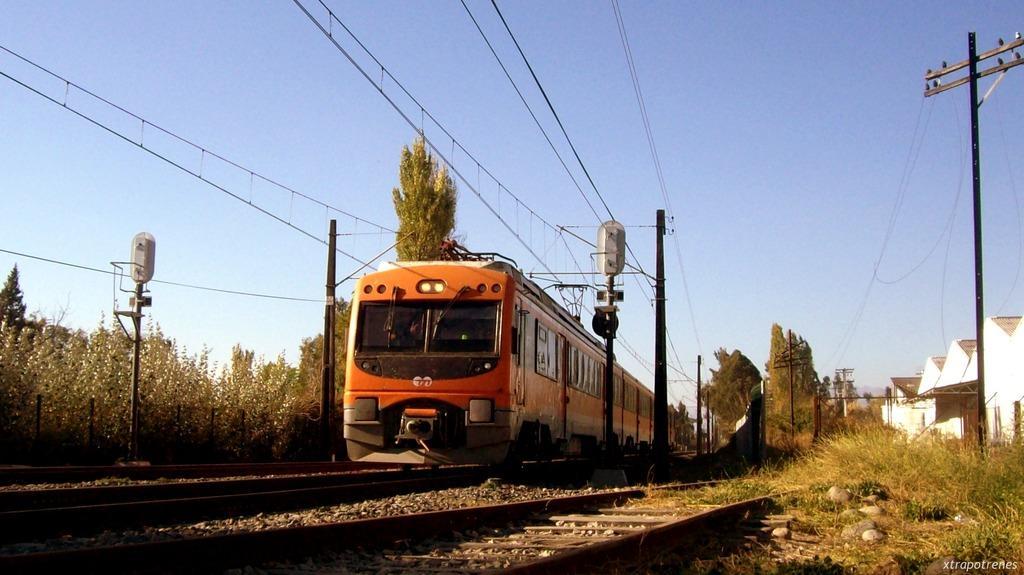Can you describe this image briefly? In the center of the image, we can see a train on the track and in the background, there are poles, lights, wires, buildings and trees. At the bottom, there are stones and there is grass. At the top, there is sky. 